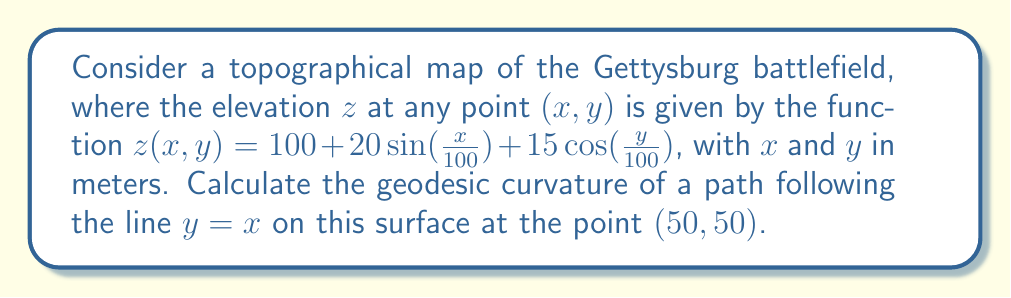Could you help me with this problem? To solve this problem, we'll follow these steps:

1) First, we need to calculate the metric tensor $g_{ij}$ of the surface. For a surface defined by $z=f(x,y)$, the metric tensor is given by:

   $$g_{11} = 1 + (\frac{\partial f}{\partial x})^2, \quad g_{12} = g_{21} = \frac{\partial f}{\partial x}\frac{\partial f}{\partial y}, \quad g_{22} = 1 + (\frac{\partial f}{\partial y})^2$$

2) Calculate the partial derivatives:
   
   $$\frac{\partial z}{\partial x} = \frac{1}{5}\cos(\frac{x}{100}), \quad \frac{\partial z}{\partial y} = -\frac{3}{20}\sin(\frac{y}{100})$$

3) At the point (50,50):
   
   $$\frac{\partial z}{\partial x} = \frac{1}{5}\cos(0.5) \approx 0.1933, \quad \frac{\partial z}{\partial y} = -\frac{3}{20}\sin(0.5) \approx -0.0739$$

4) Calculate the metric tensor components:
   
   $$g_{11} = 1 + (0.1933)^2 \approx 1.0374$$
   $$g_{12} = g_{21} = (0.1933)(-0.0739) \approx -0.0143$$
   $$g_{22} = 1 + (-0.0739)^2 \approx 1.0055$$

5) The geodesic curvature $\kappa_g$ for a curve $y=f(x)$ on a surface is given by:

   $$\kappa_g = \frac{|g_{11}f'' - 2g_{12}f'f'' + g_{22}(f')^3 - \Gamma_{11}^2(f')^2 + 2\Gamma_{12}^2f' - \Gamma_{22}^2|}{(g_{11} + 2g_{12}f' + g_{22}(f')^2)^{3/2}}$$

   Where $\Gamma_{ij}^k$ are the Christoffel symbols and $f'=1, f''=0$ for $y=x$.

6) Calculate the Christoffel symbols:
   
   $$\Gamma_{11}^2 = \frac{g^{22}}{2}(\frac{\partial g_{12}}{\partial x} + \frac{\partial g_{12}}{\partial x} - \frac{\partial g_{11}}{\partial y}) \approx 0.0071$$
   $$\Gamma_{12}^2 = \frac{g^{22}}{2}(\frac{\partial g_{22}}{\partial x}) \approx -0.0035$$
   $$\Gamma_{22}^2 = \frac{g^{22}}{2}(\frac{\partial g_{12}}{\partial y} + \frac{\partial g_{12}}{\partial y} - \frac{\partial g_{22}}{\partial x}) \approx -0.0069$$

7) Substitute these values into the geodesic curvature formula:

   $$\kappa_g = \frac{|-2(-0.0143)(1) + 1.0055(1)^3 - 0.0071(1)^2 + 2(-0.0035)(1) - (-0.0069)|}{(1.0374 + 2(-0.0143)(1) + 1.0055(1)^2)^{3/2}} \approx 0.0049$$
Answer: $\kappa_g \approx 0.0049 \text{ m}^{-1}$ 